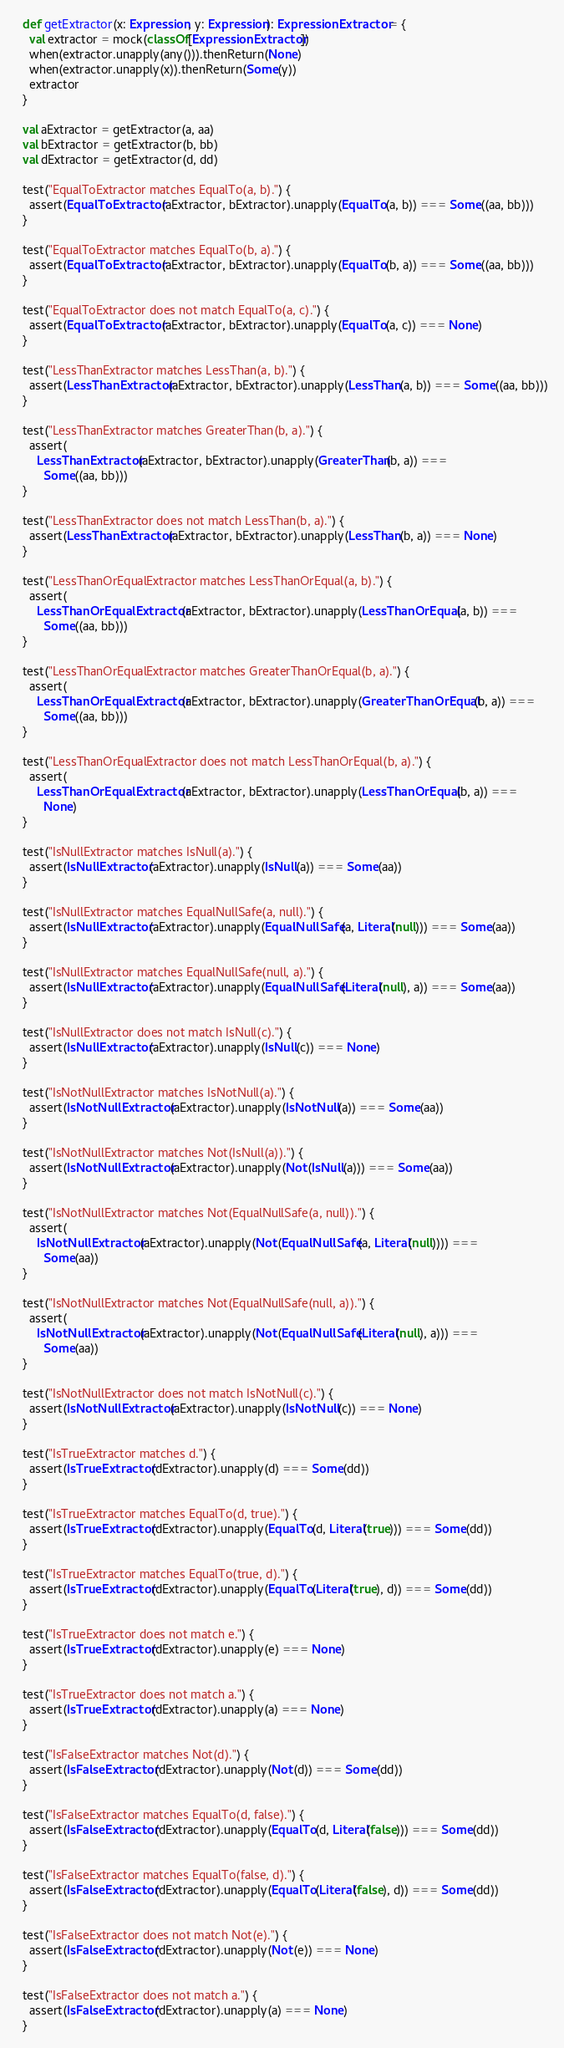<code> <loc_0><loc_0><loc_500><loc_500><_Scala_>
  def getExtractor(x: Expression, y: Expression): ExpressionExtractor = {
    val extractor = mock(classOf[ExpressionExtractor])
    when(extractor.unapply(any())).thenReturn(None)
    when(extractor.unapply(x)).thenReturn(Some(y))
    extractor
  }

  val aExtractor = getExtractor(a, aa)
  val bExtractor = getExtractor(b, bb)
  val dExtractor = getExtractor(d, dd)

  test("EqualToExtractor matches EqualTo(a, b).") {
    assert(EqualToExtractor(aExtractor, bExtractor).unapply(EqualTo(a, b)) === Some((aa, bb)))
  }

  test("EqualToExtractor matches EqualTo(b, a).") {
    assert(EqualToExtractor(aExtractor, bExtractor).unapply(EqualTo(b, a)) === Some((aa, bb)))
  }

  test("EqualToExtractor does not match EqualTo(a, c).") {
    assert(EqualToExtractor(aExtractor, bExtractor).unapply(EqualTo(a, c)) === None)
  }

  test("LessThanExtractor matches LessThan(a, b).") {
    assert(LessThanExtractor(aExtractor, bExtractor).unapply(LessThan(a, b)) === Some((aa, bb)))
  }

  test("LessThanExtractor matches GreaterThan(b, a).") {
    assert(
      LessThanExtractor(aExtractor, bExtractor).unapply(GreaterThan(b, a)) ===
        Some((aa, bb)))
  }

  test("LessThanExtractor does not match LessThan(b, a).") {
    assert(LessThanExtractor(aExtractor, bExtractor).unapply(LessThan(b, a)) === None)
  }

  test("LessThanOrEqualExtractor matches LessThanOrEqual(a, b).") {
    assert(
      LessThanOrEqualExtractor(aExtractor, bExtractor).unapply(LessThanOrEqual(a, b)) ===
        Some((aa, bb)))
  }

  test("LessThanOrEqualExtractor matches GreaterThanOrEqual(b, a).") {
    assert(
      LessThanOrEqualExtractor(aExtractor, bExtractor).unapply(GreaterThanOrEqual(b, a)) ===
        Some((aa, bb)))
  }

  test("LessThanOrEqualExtractor does not match LessThanOrEqual(b, a).") {
    assert(
      LessThanOrEqualExtractor(aExtractor, bExtractor).unapply(LessThanOrEqual(b, a)) ===
        None)
  }

  test("IsNullExtractor matches IsNull(a).") {
    assert(IsNullExtractor(aExtractor).unapply(IsNull(a)) === Some(aa))
  }

  test("IsNullExtractor matches EqualNullSafe(a, null).") {
    assert(IsNullExtractor(aExtractor).unapply(EqualNullSafe(a, Literal(null))) === Some(aa))
  }

  test("IsNullExtractor matches EqualNullSafe(null, a).") {
    assert(IsNullExtractor(aExtractor).unapply(EqualNullSafe(Literal(null), a)) === Some(aa))
  }

  test("IsNullExtractor does not match IsNull(c).") {
    assert(IsNullExtractor(aExtractor).unapply(IsNull(c)) === None)
  }

  test("IsNotNullExtractor matches IsNotNull(a).") {
    assert(IsNotNullExtractor(aExtractor).unapply(IsNotNull(a)) === Some(aa))
  }

  test("IsNotNullExtractor matches Not(IsNull(a)).") {
    assert(IsNotNullExtractor(aExtractor).unapply(Not(IsNull(a))) === Some(aa))
  }

  test("IsNotNullExtractor matches Not(EqualNullSafe(a, null)).") {
    assert(
      IsNotNullExtractor(aExtractor).unapply(Not(EqualNullSafe(a, Literal(null)))) ===
        Some(aa))
  }

  test("IsNotNullExtractor matches Not(EqualNullSafe(null, a)).") {
    assert(
      IsNotNullExtractor(aExtractor).unapply(Not(EqualNullSafe(Literal(null), a))) ===
        Some(aa))
  }

  test("IsNotNullExtractor does not match IsNotNull(c).") {
    assert(IsNotNullExtractor(aExtractor).unapply(IsNotNull(c)) === None)
  }

  test("IsTrueExtractor matches d.") {
    assert(IsTrueExtractor(dExtractor).unapply(d) === Some(dd))
  }

  test("IsTrueExtractor matches EqualTo(d, true).") {
    assert(IsTrueExtractor(dExtractor).unapply(EqualTo(d, Literal(true))) === Some(dd))
  }

  test("IsTrueExtractor matches EqualTo(true, d).") {
    assert(IsTrueExtractor(dExtractor).unapply(EqualTo(Literal(true), d)) === Some(dd))
  }

  test("IsTrueExtractor does not match e.") {
    assert(IsTrueExtractor(dExtractor).unapply(e) === None)
  }

  test("IsTrueExtractor does not match a.") {
    assert(IsTrueExtractor(dExtractor).unapply(a) === None)
  }

  test("IsFalseExtractor matches Not(d).") {
    assert(IsFalseExtractor(dExtractor).unapply(Not(d)) === Some(dd))
  }

  test("IsFalseExtractor matches EqualTo(d, false).") {
    assert(IsFalseExtractor(dExtractor).unapply(EqualTo(d, Literal(false))) === Some(dd))
  }

  test("IsFalseExtractor matches EqualTo(false, d).") {
    assert(IsFalseExtractor(dExtractor).unapply(EqualTo(Literal(false), d)) === Some(dd))
  }

  test("IsFalseExtractor does not match Not(e).") {
    assert(IsFalseExtractor(dExtractor).unapply(Not(e)) === None)
  }

  test("IsFalseExtractor does not match a.") {
    assert(IsFalseExtractor(dExtractor).unapply(a) === None)
  }
</code> 